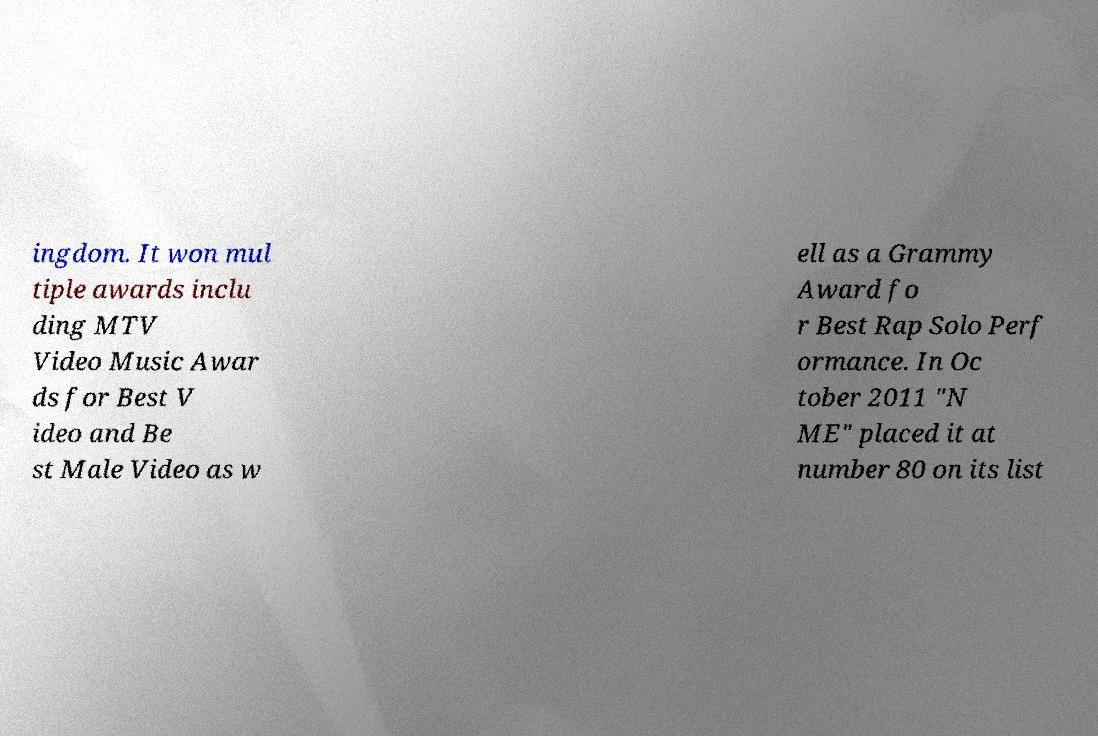Can you accurately transcribe the text from the provided image for me? ingdom. It won mul tiple awards inclu ding MTV Video Music Awar ds for Best V ideo and Be st Male Video as w ell as a Grammy Award fo r Best Rap Solo Perf ormance. In Oc tober 2011 "N ME" placed it at number 80 on its list 